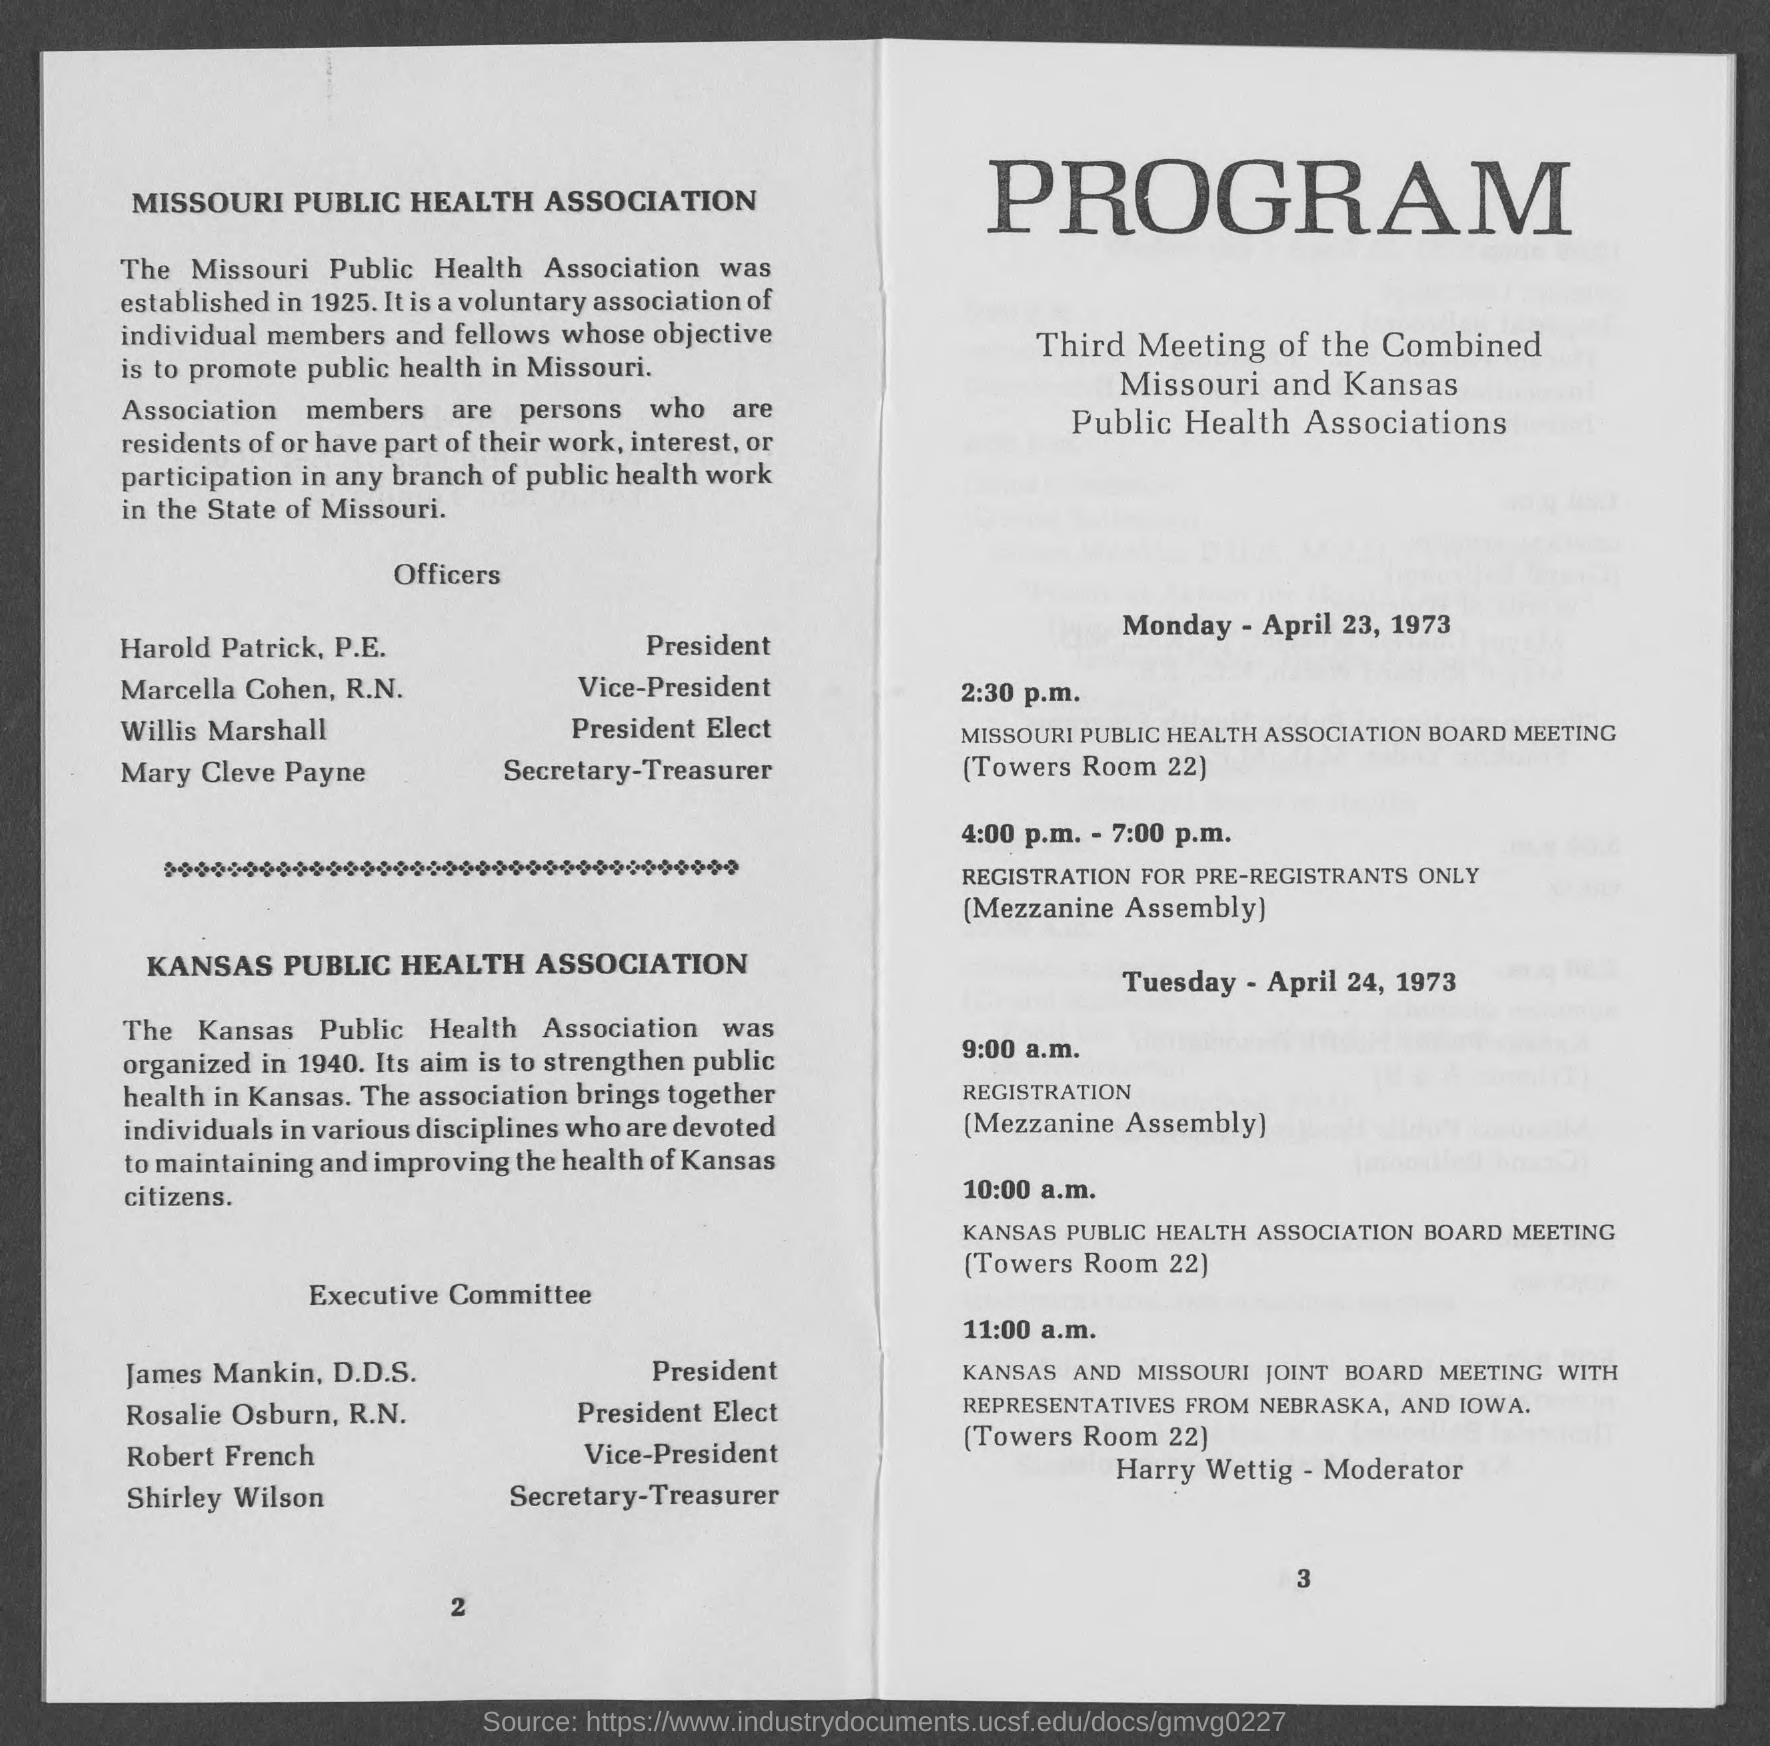Who is the president of missouri public health association?
Ensure brevity in your answer.  Harold Patrick, P.E. Who is the vice-president of missouri public health association?
Provide a succinct answer. Marcella Cohen, R.N. Who is the president elect of  missouri public health association?
Keep it short and to the point. Willis Marshall. Who is the secretary- treasurer of  missouri public health association?
Provide a short and direct response. Mary Cleve Payne. Who is the president of kansas public health association?
Provide a succinct answer. James Mankin, D.D.S. Who is the president elect of kansas public health association?
Your answer should be very brief. Rosalie Osburn, R.N. Who is the vice- president of kansas public health association?
Your answer should be compact. Robert French. Who is the secretary- treasurer of kansas public health association?
Your response must be concise. Shirley Wilson. 